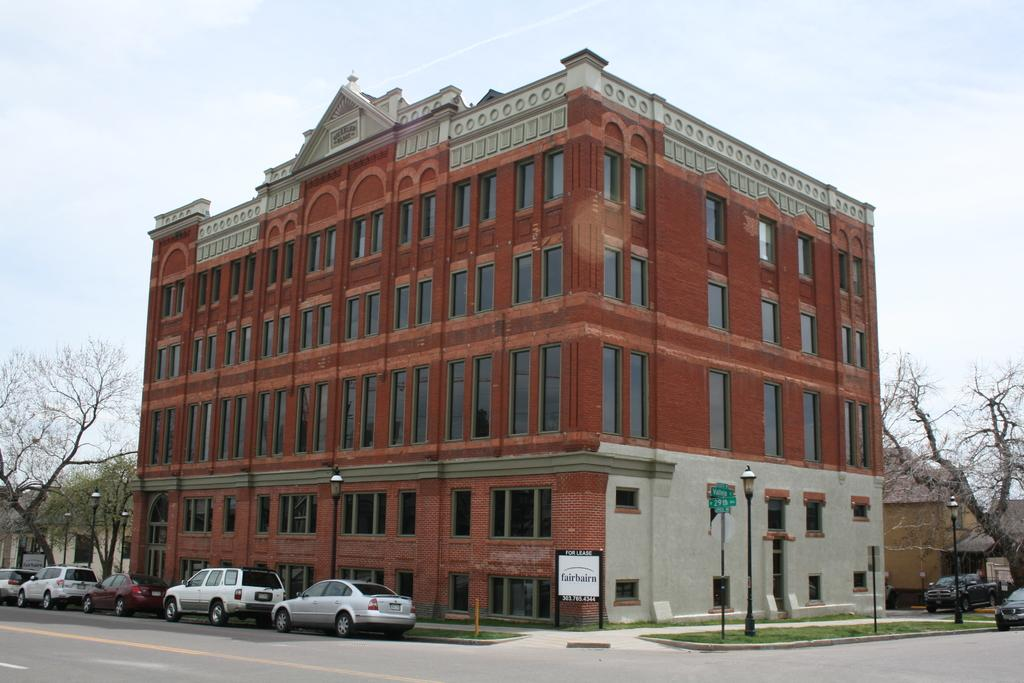What type of structures can be seen in the image? There are buildings in the image. What else is present in the image besides buildings? There are vehicles, trees, poles, lights, grass, and boards with text in the image. Can you describe the environment in the image? The environment includes trees, grass, and the sky visible in the background. What might be used for illumination in the image? There are lights in the image that could be used for illumination. What can be seen on the boards with text in the image? The content of the text on the boards cannot be determined from the image. What type of underwear is hanging on the pole in the image? There is no underwear present in the image; only buildings, vehicles, trees, poles, lights, grass, boards with text, and the sky are visible. What is the belief system of the people in the image? The image does not provide any information about the belief system of the people in the image. 